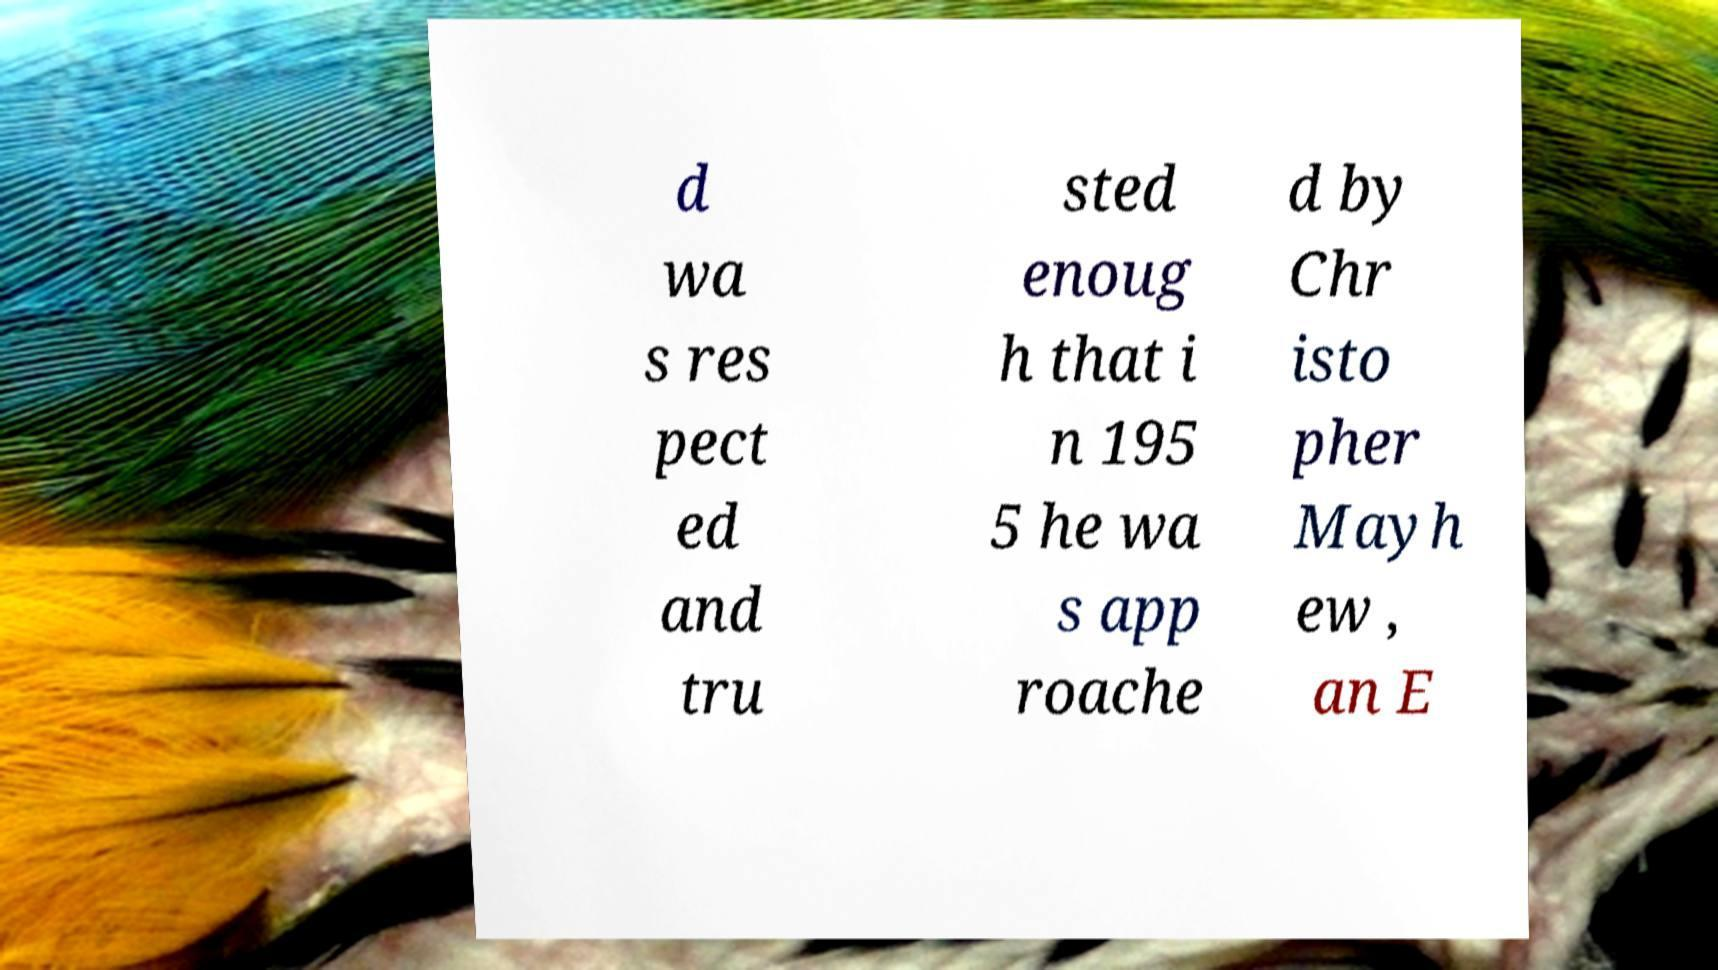What messages or text are displayed in this image? I need them in a readable, typed format. d wa s res pect ed and tru sted enoug h that i n 195 5 he wa s app roache d by Chr isto pher Mayh ew , an E 